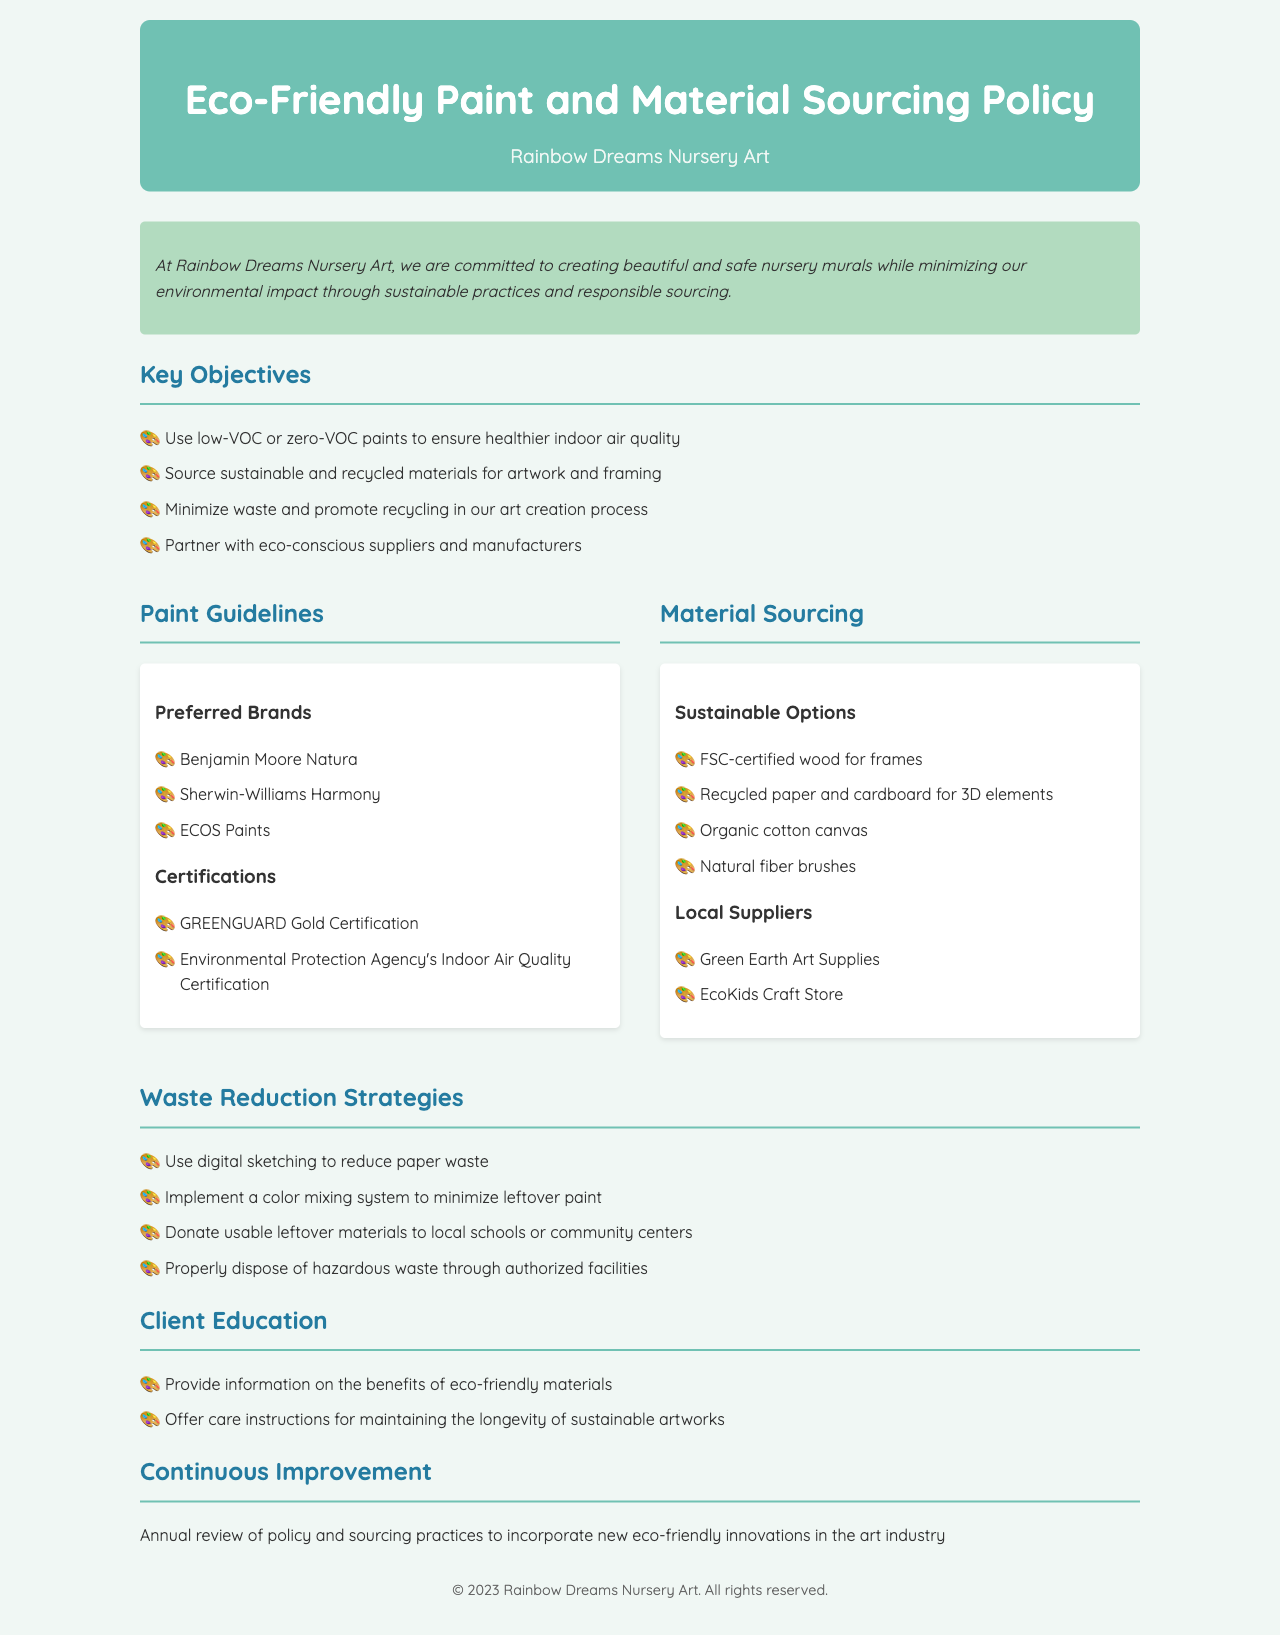what is the company name? The company name is the title mentioned in the document, which is "Rainbow Dreams Nursery Art."
Answer: Rainbow Dreams Nursery Art what types of paints are preferred? The document specifies the types of paints that are preferred for use in the projects, which include low-VOC or zero-VOC paints.
Answer: low-VOC or zero-VOC how many preferred paint brands are listed? The document lists three preferred paint brands under the Paint Guidelines section.
Answer: three what is one sustainable option for materials? The document highlights sustainable options for sourcing materials, one of which is FSC-certified wood for frames.
Answer: FSC-certified wood for frames what is a waste reduction strategy mentioned? The waste reduction strategies are outlined in the document, and one strategy mentioned is using digital sketching to reduce paper waste.
Answer: digital sketching name a local supplier of eco-friendly materials. The document lists local suppliers in the Material Sourcing section, one of which is Green Earth Art Supplies.
Answer: Green Earth Art Supplies what certification indicates good indoor air quality? The document mentions certifications for the paints, including GREENGUARD Gold Certification, which indicates good indoor air quality.
Answer: GREENGUARD Gold Certification what is the focus of the Continuous Improvement section? The Continuous Improvement section describes the focus on reviewing the policy and sourcing practices annually to adapt to new eco-friendly innovations.
Answer: annual review what does the company provide to educate clients? The Client Education section details the information the company provides, which includes benefits of eco-friendly materials.
Answer: benefits of eco-friendly materials 